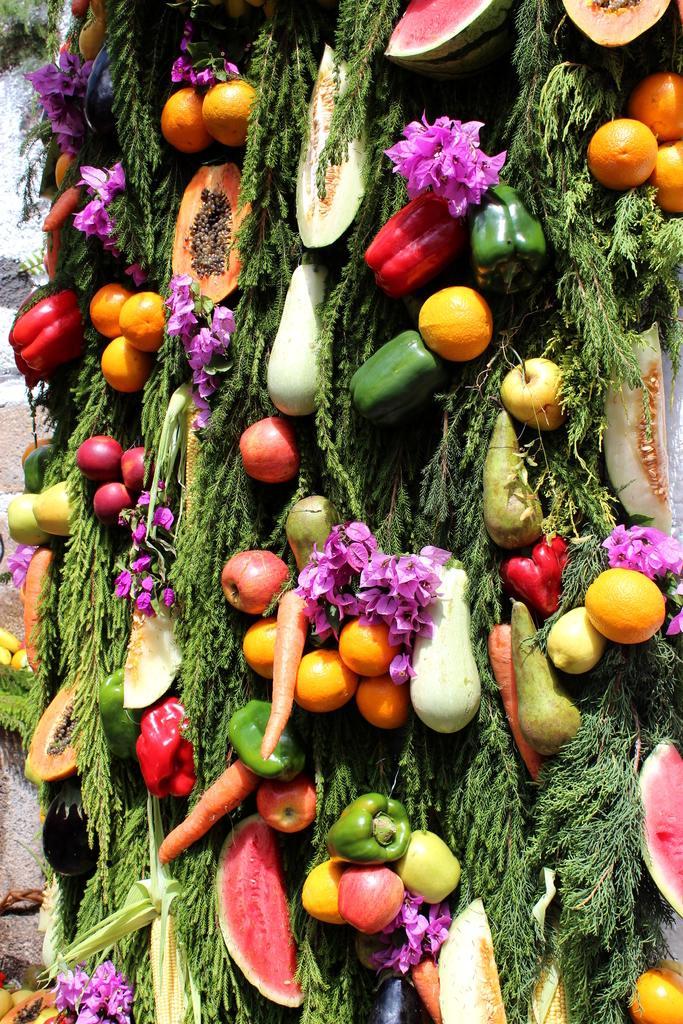Could you give a brief overview of what you see in this image? In this image I can see many vegetables and fruits like oranges, capsicum, apples, carrot, watermelon, papaya and some other. Along with these I can see the leaves and flowers. In the background there is a wall. 